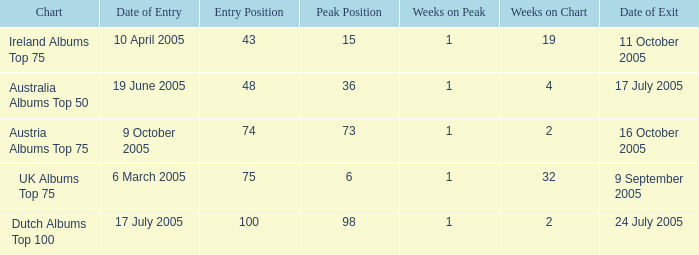What was the total number of weeks on peak for the Ireland Albums Top 75 chart? 1.0. 